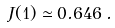<formula> <loc_0><loc_0><loc_500><loc_500>J ( 1 ) \simeq 0 . 6 4 6 \, .</formula> 